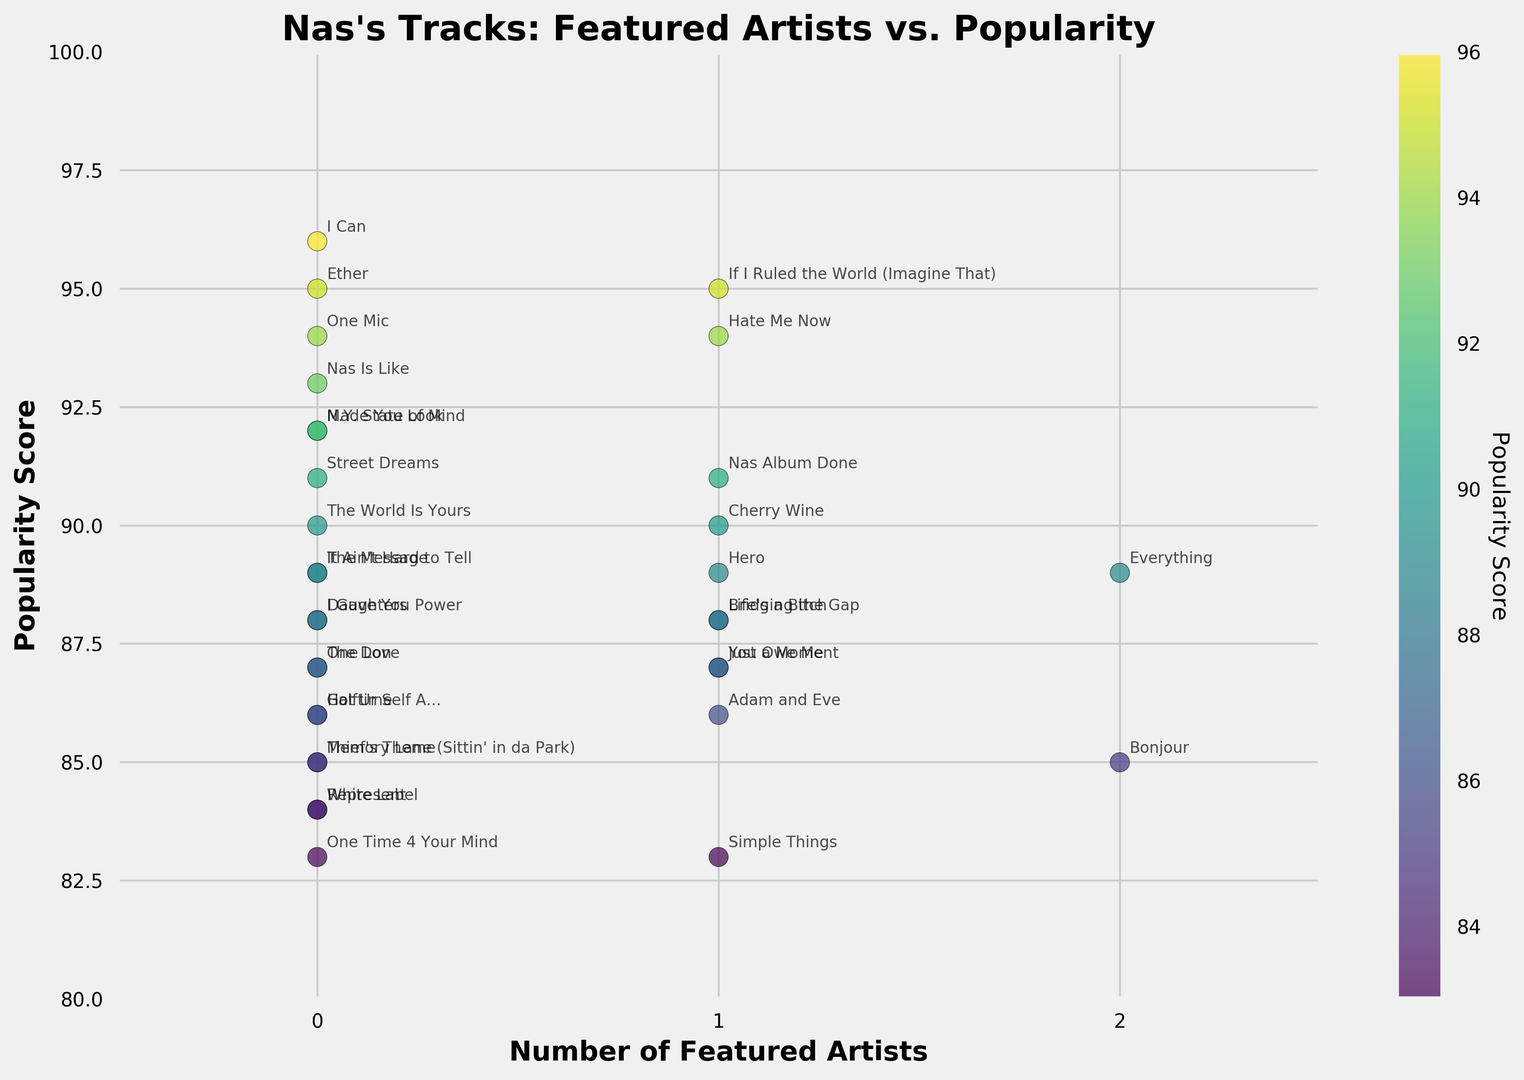What is the overall trend between the number of featured artists and track popularity? The scatter plot reveals a somewhat mixed trend. Tracks with 0 or 1 featured artists generally have high popularity scores, but there is no clear monotonic relationship indicating that more featured artists always lead to higher popularity.
Answer: Mixed trend Which track has the highest popularity score and how many featured artists does it have? "I Can" has the highest popularity score of 96 and it has 0 featured artists.
Answer: I Can, 0 Which track features the most artists and how popular is it? "Bonjour" and "Everything" both feature the most artists, with 2 each. "Everything" has a higher popularity score of 89 compared to "Bonjour"'s 85.
Answer: Everything, 89 How many tracks have a popularity score greater than 90? The scatter plot shows that there are 8 tracks with popularity scores greater than 90.
Answer: 8 What is the average popularity score for tracks with 1 featured artist? The tracks with 1 featured artist are "Life's a Bitch", "If I Ruled the World (Imagine That)", "Hate Me Now", "You Owe Me", "Bridging the Gap", "Just a Moment", "Hero", "Nas Album Done", "Adam and Eve", and "Simple Things". Adding their popularity scores (88 + 95 + 94 + 87 + 88 + 87 + 89 + 91 + 86 + 83) gives 798. Dividing by 10 tracks, the average is 79.8.
Answer: 79.8 Do tracks with no featured artists tend to be more popular than those with featured artists? When examining the scatter plot, tracks without featured artists generally appear to have higher popularity scores, with several scores above 90, compared to those with featured artists.
Answer: Yes Which track with 1 featured artist has the highest popularity score? "If I Ruled the World (Imagine That)" has the highest popularity score of 95 among tracks with 1 featured artist.
Answer: If I Ruled the World (Imagine That) What is the range of popularity scores for tracks with no featured artists? The lowest popularity score for tracks with no featured artists is 83 ("One Time 4 Your Mind") and the highest is 96 ("I Can"), providing a range of 96 - 83 = 13.
Answer: 13 Compare the average popularity scores between tracks with 0 featured artists and those with 1. Which is higher? For tracks with 0 featured artists: sum of scores is 1304 over 15 tracks, average = 1304 / 15 ≈ 86.93. For tracks with 1 featured artist: sum is 798 over 10 tracks, average = 798 / 10 = 79.8. Thus, tracks with 0 featured artists have a higher average.
Answer: 0 featured artists higher What is the median popularity score for tracks with 2 featured artists? The median popularity score for tracks with 2 featured artists is calculated by ordering their scores: 85 (Bonjour), 89 (Everything). With two data points, the median is the average of these, (85 + 89) / 2 = 87.
Answer: 87 